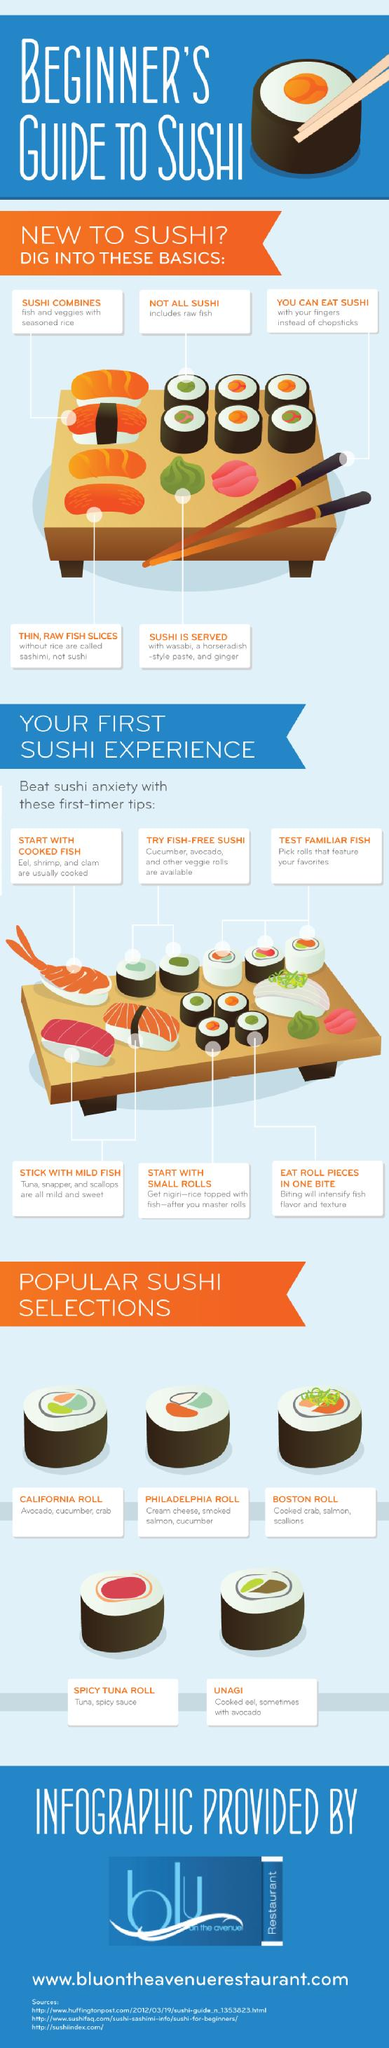Highlight a few significant elements in this photo. The second to last Sushi mentioned under the Popular Sushi selection is the Spicy Tuna Roll. California Roll is a popular sushi dish that consists of the following major ingredients: avocado, cucumber, and crab. Six tips are mentioned for first-time users of Sushi. Sushi is a Japanese culinary specialty consisting of seasoned rice combined with raw or cooked seafood and other ingredients, such as vegetables, often wrapped in edible seaweed. There are a variety of Sushi options available, ranging from 5.. 